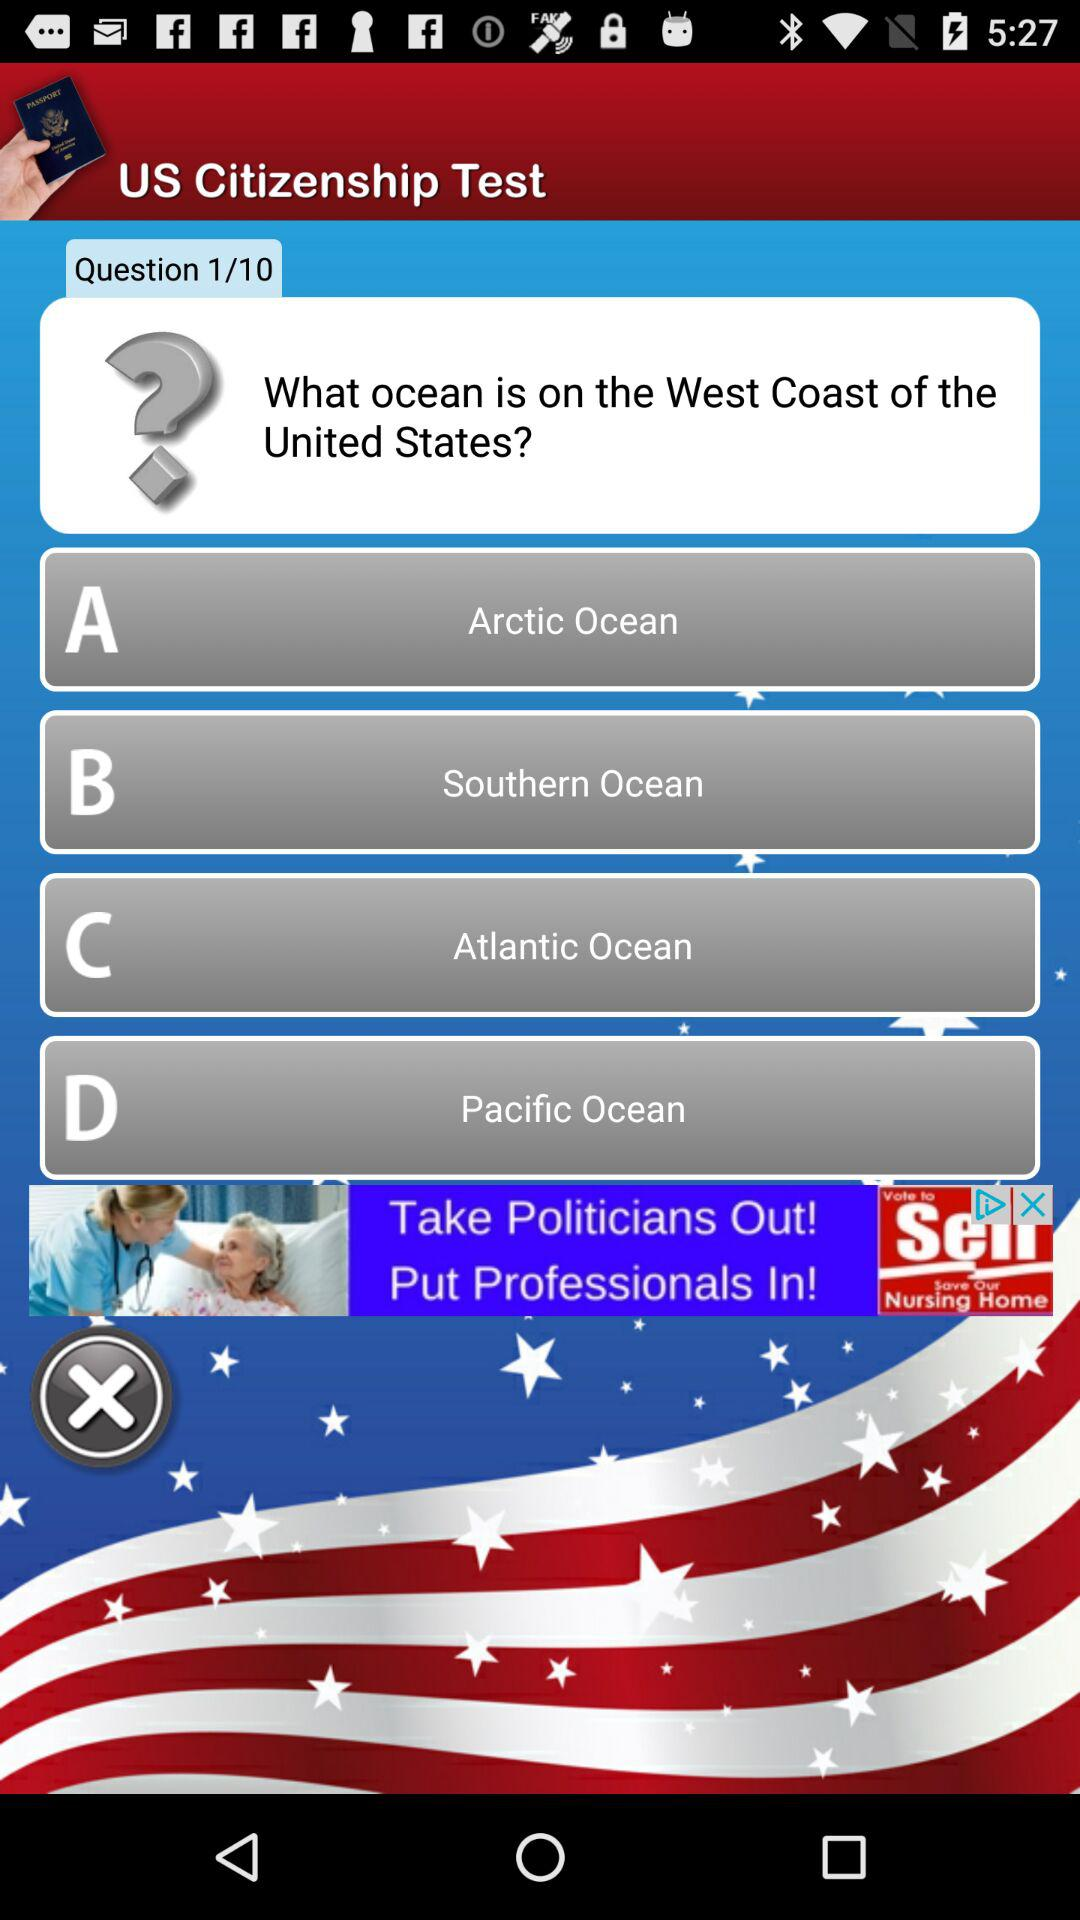How many options are there in the question?
Answer the question using a single word or phrase. 4 